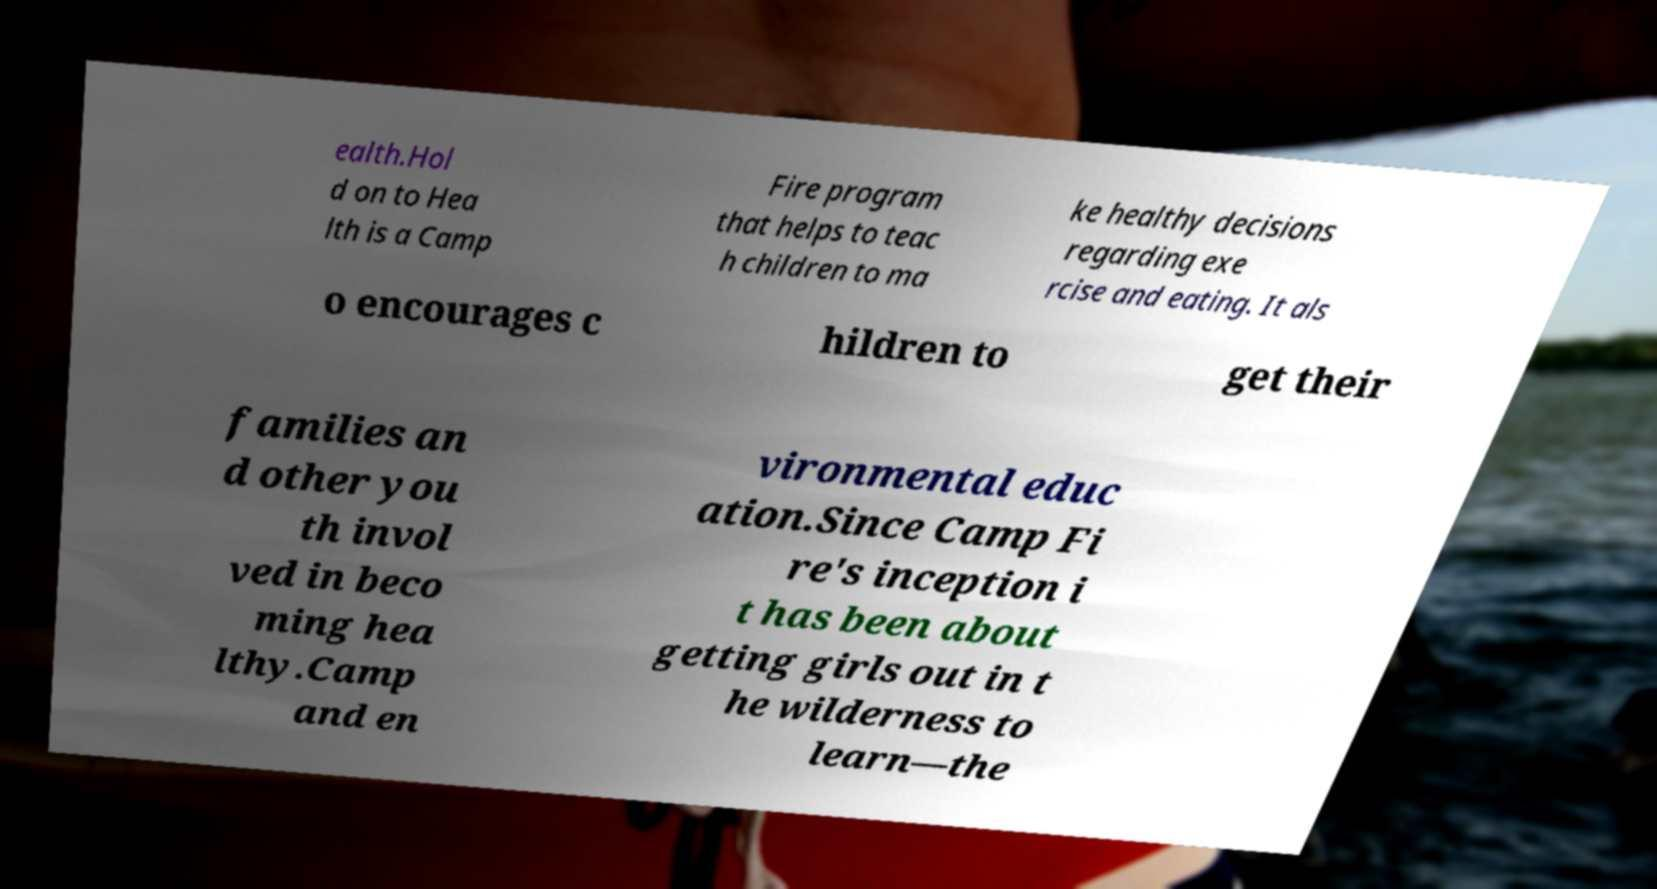What messages or text are displayed in this image? I need them in a readable, typed format. ealth.Hol d on to Hea lth is a Camp Fire program that helps to teac h children to ma ke healthy decisions regarding exe rcise and eating. It als o encourages c hildren to get their families an d other you th invol ved in beco ming hea lthy.Camp and en vironmental educ ation.Since Camp Fi re's inception i t has been about getting girls out in t he wilderness to learn—the 